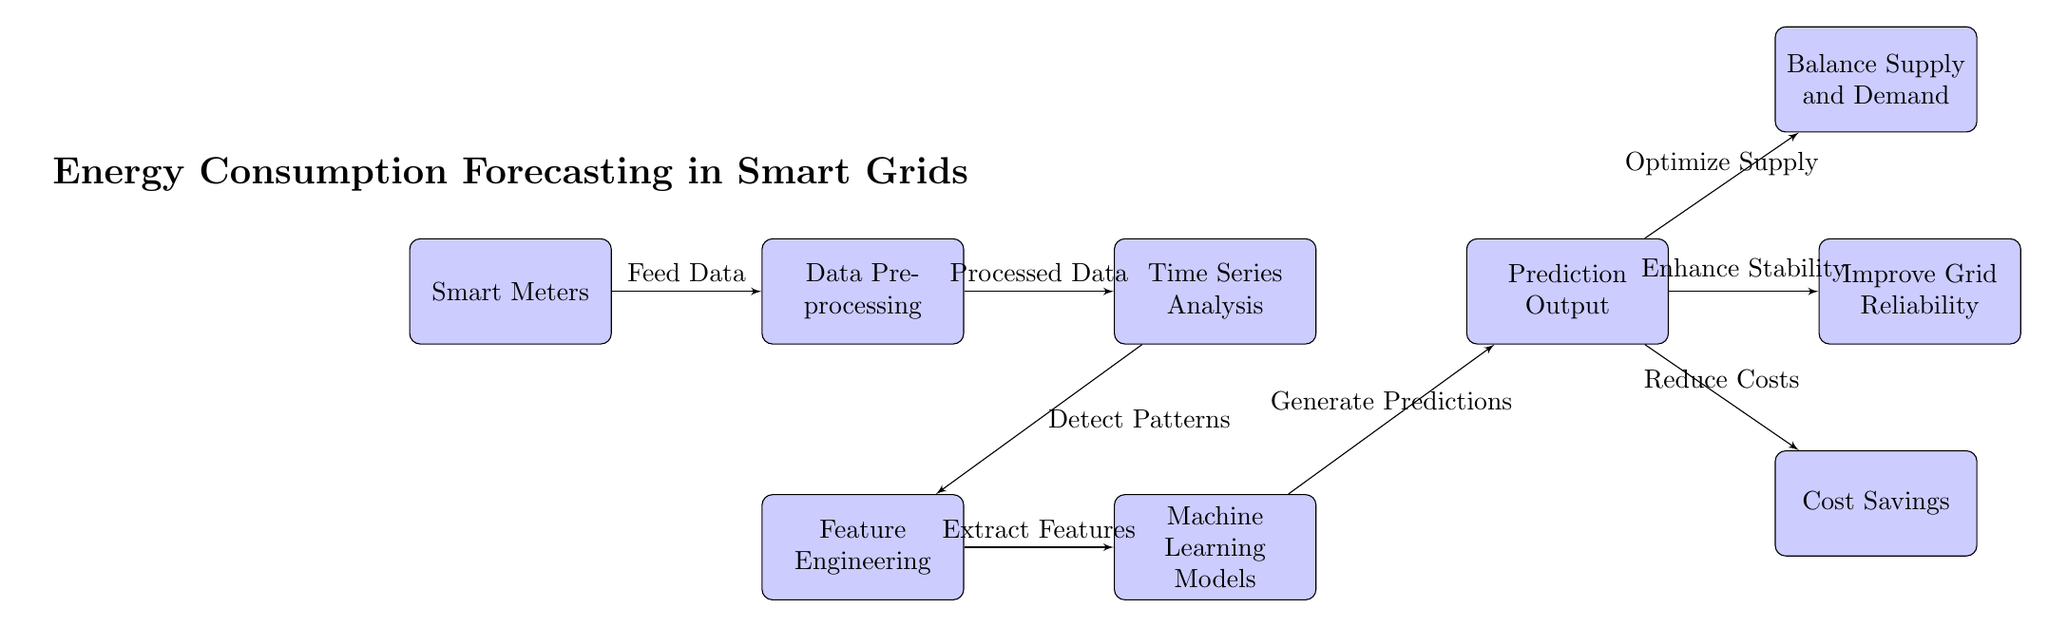What is the first block in the diagram? The first block in the diagram is "Smart Meters," which is positioned at the far left.
Answer: Smart Meters How many blocks are in the diagram? There are a total of seven blocks visible in the diagram. Each block represents a key component in the energy consumption forecasting process.
Answer: Seven What type of analysis is performed after data preprocessing? After data preprocessing, "Time Series Analysis" is conducted, as indicated by the flow from the second block to the third block.
Answer: Time Series Analysis What do the predictions in the diagram optimize for? The predictions generated by the machine learning models optimize for "Supply" in the smart grid system, as shown by the arrow leading to the node "Balance Supply and Demand."
Answer: Supply Which node shows the cost savings benefit? The node that indicates cost savings is labeled "Cost Savings," which is situated below and right of the "Prediction Output" block.
Answer: Cost Savings Which blocks contribute to grid reliability based on the diagram? The block "Improve Grid Reliability" directly follows the "Prediction Output" block, signifying its contribution to enhancing reliability in the grid.
Answer: Improve Grid Reliability What is the function of the "Feature Engineering" block? The "Feature Engineering" block serves to "Extract Features," which is a necessary step before applying machine learning models, as indicated by the flow from the "Feature Engineering" block to the "Machine Learning Models" block.
Answer: Extract Features Describe the relationship between "Machine Learning Models" and "Prediction Output". The "Machine Learning Models" block outputs "Generate Predictions" which feed directly into the "Prediction Output" block, hence showing a direct processing relationship.
Answer: Generate Predictions What role do smart meters play in this diagram? Smart meters play the role of feeding data into the system, initiating the process of energy consumption forecasting.
Answer: Feed Data 